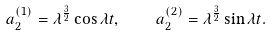Convert formula to latex. <formula><loc_0><loc_0><loc_500><loc_500>a _ { 2 } ^ { ( 1 ) } = \lambda ^ { \frac { 3 } { 2 } } \cos \lambda t , \quad a _ { 2 } ^ { ( 2 ) } = \lambda ^ { \frac { 3 } { 2 } } \sin \lambda t .</formula> 